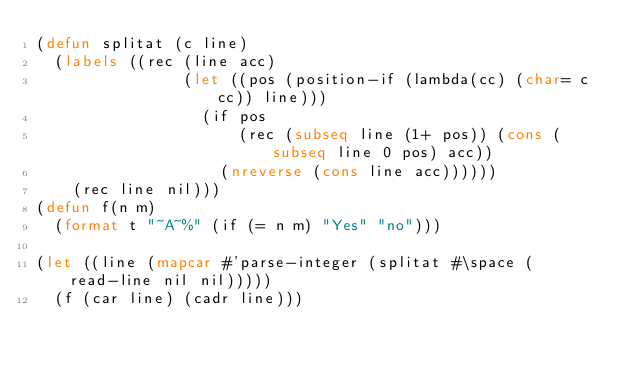<code> <loc_0><loc_0><loc_500><loc_500><_Lisp_>(defun splitat (c line)
  (labels ((rec (line acc)
				(let ((pos (position-if (lambda(cc) (char= c cc)) line)))
				  (if pos
					  (rec (subseq line (1+ pos)) (cons (subseq line 0 pos) acc))
					(nreverse (cons line acc))))))
	(rec line nil)))
(defun f(n m)
  (format t "~A~%" (if (= n m) "Yes" "no")))

(let ((line (mapcar #'parse-integer (splitat #\space (read-line nil nil)))))
  (f (car line) (cadr line)))
</code> 